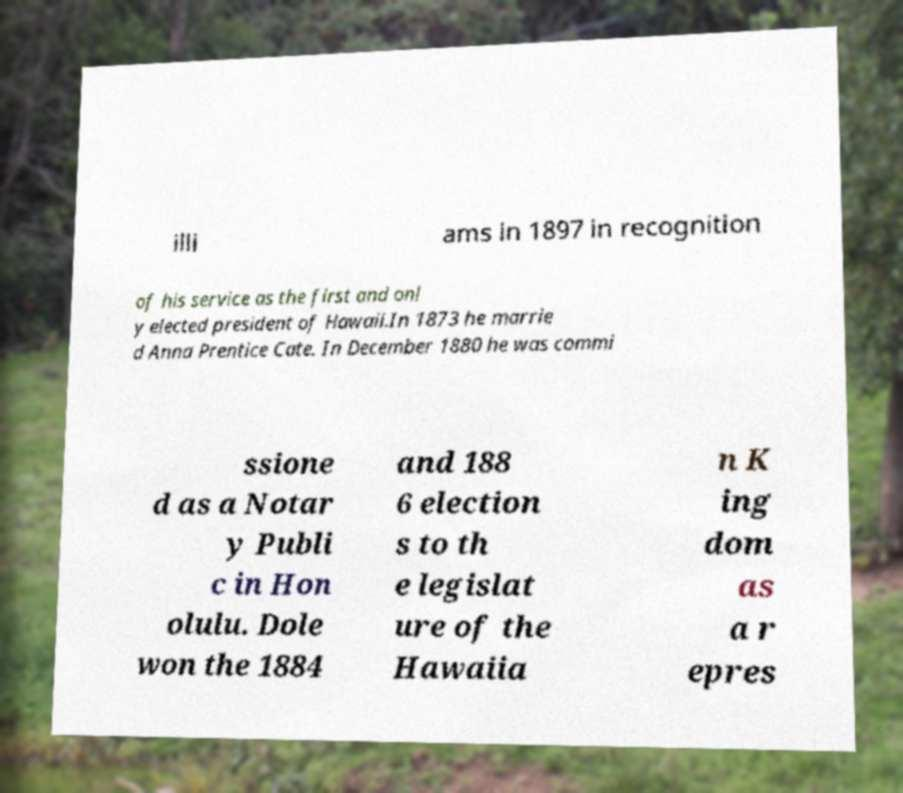There's text embedded in this image that I need extracted. Can you transcribe it verbatim? illi ams in 1897 in recognition of his service as the first and onl y elected president of Hawaii.In 1873 he marrie d Anna Prentice Cate. In December 1880 he was commi ssione d as a Notar y Publi c in Hon olulu. Dole won the 1884 and 188 6 election s to th e legislat ure of the Hawaiia n K ing dom as a r epres 